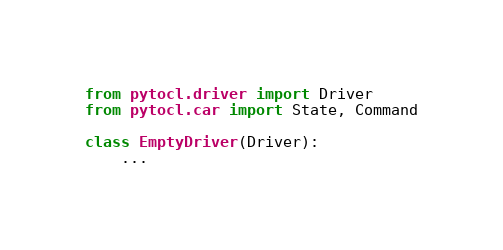Convert code to text. <code><loc_0><loc_0><loc_500><loc_500><_Python_>from pytocl.driver import Driver
from pytocl.car import State, Command

class EmptyDriver(Driver):
	...
</code> 